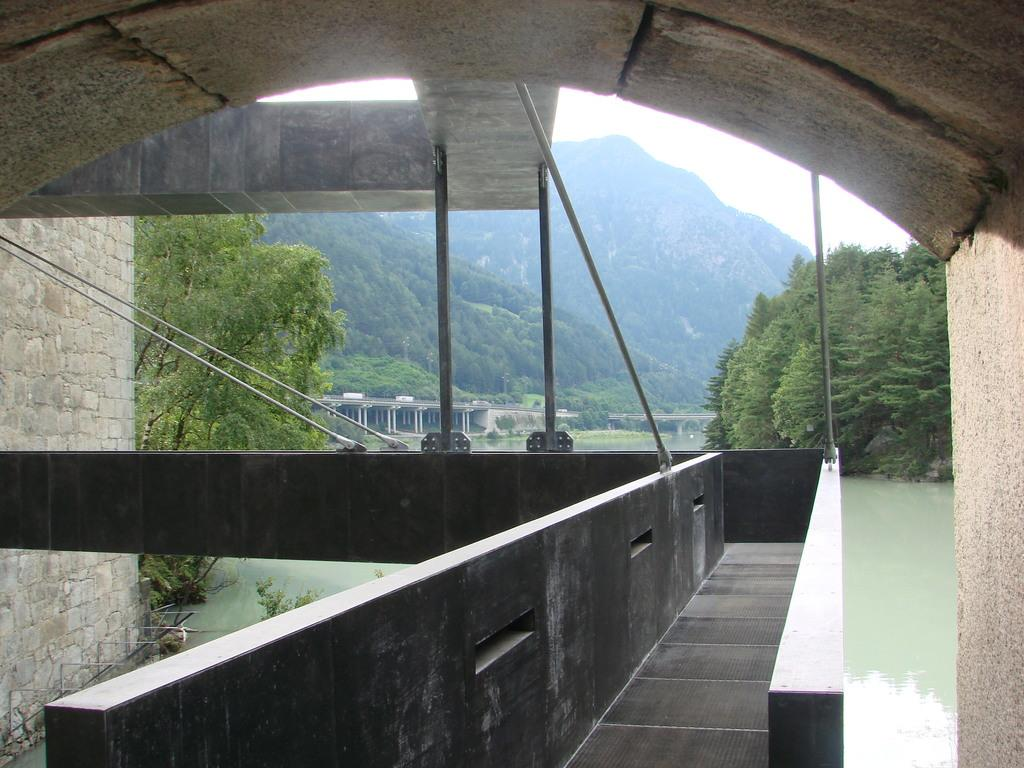What is located on the left side of the image? There is a wall on the left side of the image. What can be seen in the distance in the image? There are mountains in the background of the image. What type of vegetation is present in the image? There are trees in the image. What structure is visible in the image? There is a bridge in the image. What is visible at the bottom of the image? There is water visible at the bottom of the image. What type of book is floating on the water in the image? There is no book present in the image; it features a wall, mountains, trees, a bridge, and water. What type of zipper can be seen on the trees in the image? There are no zippers present on trees in the image; it is a natural scene with no man-made objects attached to the trees. 